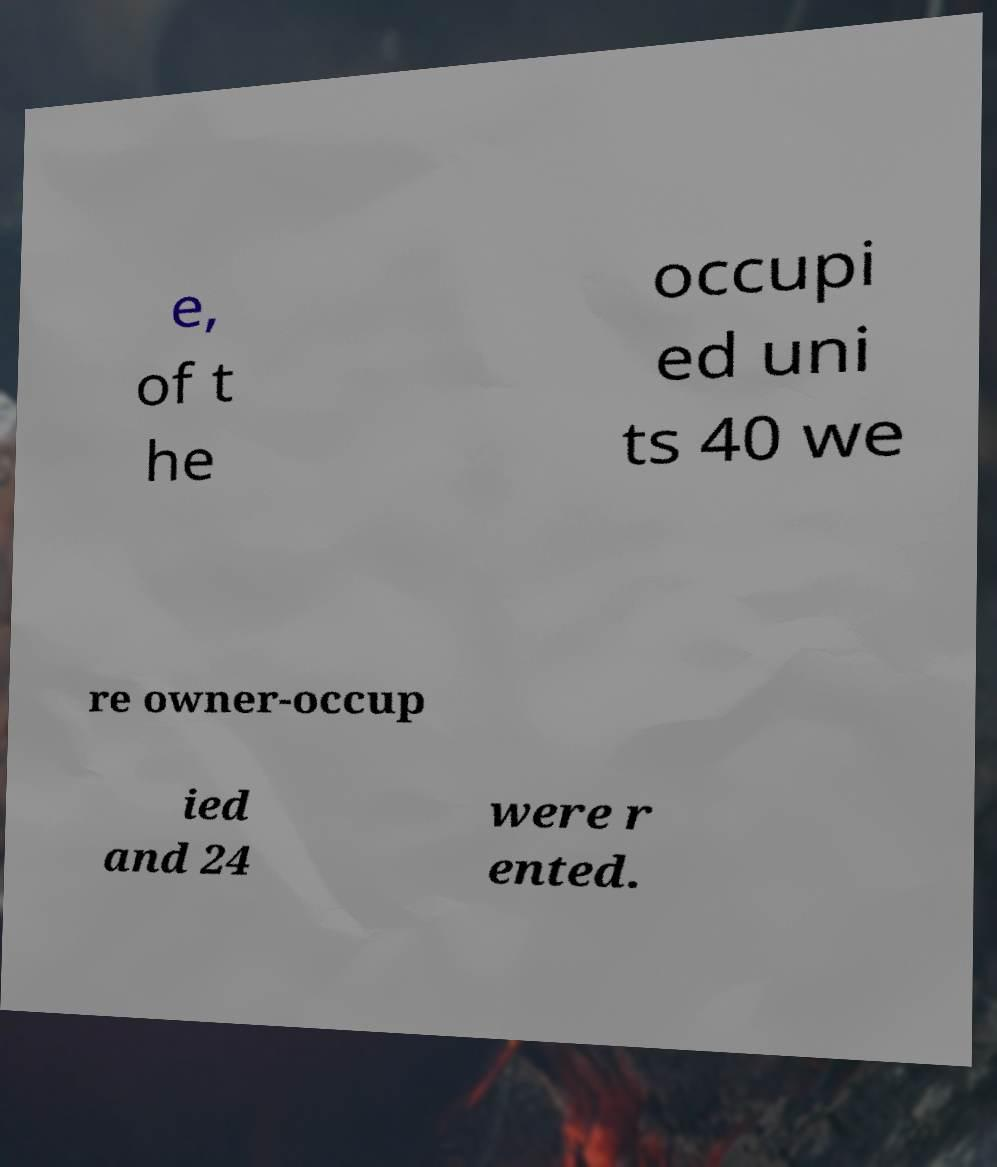I need the written content from this picture converted into text. Can you do that? e, of t he occupi ed uni ts 40 we re owner-occup ied and 24 were r ented. 